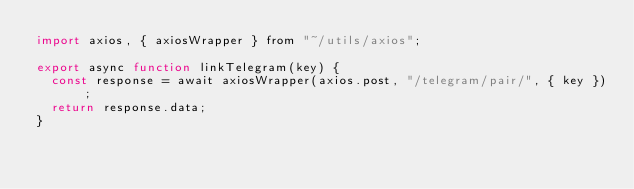<code> <loc_0><loc_0><loc_500><loc_500><_JavaScript_>import axios, { axiosWrapper } from "~/utils/axios";

export async function linkTelegram(key) {
	const response = await axiosWrapper(axios.post, "/telegram/pair/", { key });
	return response.data;
}
</code> 